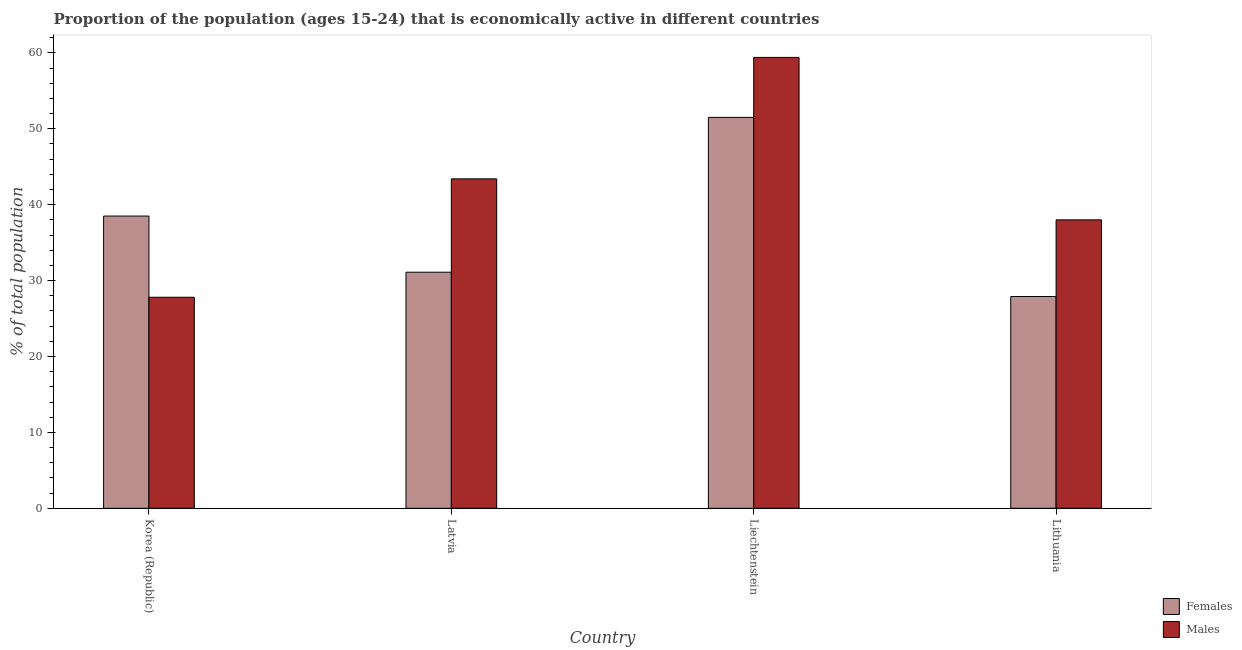How many different coloured bars are there?
Give a very brief answer. 2. How many groups of bars are there?
Keep it short and to the point. 4. Are the number of bars on each tick of the X-axis equal?
Your response must be concise. Yes. How many bars are there on the 1st tick from the right?
Provide a short and direct response. 2. What is the label of the 2nd group of bars from the left?
Offer a very short reply. Latvia. In how many cases, is the number of bars for a given country not equal to the number of legend labels?
Your response must be concise. 0. What is the percentage of economically active female population in Lithuania?
Make the answer very short. 27.9. Across all countries, what is the maximum percentage of economically active female population?
Give a very brief answer. 51.5. Across all countries, what is the minimum percentage of economically active male population?
Keep it short and to the point. 27.8. In which country was the percentage of economically active female population maximum?
Offer a terse response. Liechtenstein. In which country was the percentage of economically active female population minimum?
Offer a terse response. Lithuania. What is the total percentage of economically active male population in the graph?
Your response must be concise. 168.6. What is the difference between the percentage of economically active male population in Korea (Republic) and that in Liechtenstein?
Ensure brevity in your answer.  -31.6. What is the difference between the percentage of economically active female population in Korea (Republic) and the percentage of economically active male population in Latvia?
Ensure brevity in your answer.  -4.9. What is the average percentage of economically active female population per country?
Your response must be concise. 37.25. What is the difference between the percentage of economically active female population and percentage of economically active male population in Liechtenstein?
Keep it short and to the point. -7.9. What is the ratio of the percentage of economically active male population in Korea (Republic) to that in Latvia?
Offer a very short reply. 0.64. Is the difference between the percentage of economically active male population in Korea (Republic) and Lithuania greater than the difference between the percentage of economically active female population in Korea (Republic) and Lithuania?
Your answer should be compact. No. What is the difference between the highest and the lowest percentage of economically active male population?
Offer a terse response. 31.6. In how many countries, is the percentage of economically active male population greater than the average percentage of economically active male population taken over all countries?
Your answer should be compact. 2. Is the sum of the percentage of economically active male population in Liechtenstein and Lithuania greater than the maximum percentage of economically active female population across all countries?
Your answer should be very brief. Yes. What does the 1st bar from the left in Liechtenstein represents?
Your answer should be very brief. Females. What does the 2nd bar from the right in Liechtenstein represents?
Your answer should be very brief. Females. How many bars are there?
Provide a short and direct response. 8. How many countries are there in the graph?
Provide a succinct answer. 4. How are the legend labels stacked?
Give a very brief answer. Vertical. What is the title of the graph?
Give a very brief answer. Proportion of the population (ages 15-24) that is economically active in different countries. What is the label or title of the X-axis?
Your response must be concise. Country. What is the label or title of the Y-axis?
Your answer should be very brief. % of total population. What is the % of total population of Females in Korea (Republic)?
Offer a terse response. 38.5. What is the % of total population of Males in Korea (Republic)?
Offer a terse response. 27.8. What is the % of total population of Females in Latvia?
Give a very brief answer. 31.1. What is the % of total population of Males in Latvia?
Your answer should be compact. 43.4. What is the % of total population of Females in Liechtenstein?
Give a very brief answer. 51.5. What is the % of total population of Males in Liechtenstein?
Your response must be concise. 59.4. What is the % of total population of Females in Lithuania?
Your answer should be compact. 27.9. What is the % of total population in Males in Lithuania?
Your answer should be compact. 38. Across all countries, what is the maximum % of total population in Females?
Your response must be concise. 51.5. Across all countries, what is the maximum % of total population of Males?
Make the answer very short. 59.4. Across all countries, what is the minimum % of total population of Females?
Your answer should be compact. 27.9. Across all countries, what is the minimum % of total population in Males?
Ensure brevity in your answer.  27.8. What is the total % of total population in Females in the graph?
Your answer should be very brief. 149. What is the total % of total population of Males in the graph?
Provide a succinct answer. 168.6. What is the difference between the % of total population of Females in Korea (Republic) and that in Latvia?
Your answer should be very brief. 7.4. What is the difference between the % of total population in Males in Korea (Republic) and that in Latvia?
Your answer should be very brief. -15.6. What is the difference between the % of total population of Males in Korea (Republic) and that in Liechtenstein?
Ensure brevity in your answer.  -31.6. What is the difference between the % of total population in Females in Latvia and that in Liechtenstein?
Provide a succinct answer. -20.4. What is the difference between the % of total population of Males in Latvia and that in Liechtenstein?
Your answer should be compact. -16. What is the difference between the % of total population of Females in Latvia and that in Lithuania?
Offer a very short reply. 3.2. What is the difference between the % of total population in Males in Latvia and that in Lithuania?
Your answer should be very brief. 5.4. What is the difference between the % of total population of Females in Liechtenstein and that in Lithuania?
Offer a terse response. 23.6. What is the difference between the % of total population of Males in Liechtenstein and that in Lithuania?
Offer a very short reply. 21.4. What is the difference between the % of total population of Females in Korea (Republic) and the % of total population of Males in Liechtenstein?
Your answer should be compact. -20.9. What is the difference between the % of total population of Females in Latvia and the % of total population of Males in Liechtenstein?
Offer a terse response. -28.3. What is the average % of total population in Females per country?
Offer a terse response. 37.25. What is the average % of total population in Males per country?
Offer a terse response. 42.15. What is the difference between the % of total population in Females and % of total population in Males in Latvia?
Offer a very short reply. -12.3. What is the difference between the % of total population of Females and % of total population of Males in Liechtenstein?
Provide a succinct answer. -7.9. What is the difference between the % of total population of Females and % of total population of Males in Lithuania?
Give a very brief answer. -10.1. What is the ratio of the % of total population of Females in Korea (Republic) to that in Latvia?
Ensure brevity in your answer.  1.24. What is the ratio of the % of total population in Males in Korea (Republic) to that in Latvia?
Keep it short and to the point. 0.64. What is the ratio of the % of total population of Females in Korea (Republic) to that in Liechtenstein?
Your answer should be very brief. 0.75. What is the ratio of the % of total population of Males in Korea (Republic) to that in Liechtenstein?
Offer a very short reply. 0.47. What is the ratio of the % of total population of Females in Korea (Republic) to that in Lithuania?
Offer a terse response. 1.38. What is the ratio of the % of total population in Males in Korea (Republic) to that in Lithuania?
Ensure brevity in your answer.  0.73. What is the ratio of the % of total population in Females in Latvia to that in Liechtenstein?
Offer a terse response. 0.6. What is the ratio of the % of total population in Males in Latvia to that in Liechtenstein?
Provide a succinct answer. 0.73. What is the ratio of the % of total population of Females in Latvia to that in Lithuania?
Keep it short and to the point. 1.11. What is the ratio of the % of total population in Males in Latvia to that in Lithuania?
Make the answer very short. 1.14. What is the ratio of the % of total population in Females in Liechtenstein to that in Lithuania?
Give a very brief answer. 1.85. What is the ratio of the % of total population of Males in Liechtenstein to that in Lithuania?
Offer a terse response. 1.56. What is the difference between the highest and the lowest % of total population of Females?
Keep it short and to the point. 23.6. What is the difference between the highest and the lowest % of total population in Males?
Offer a very short reply. 31.6. 